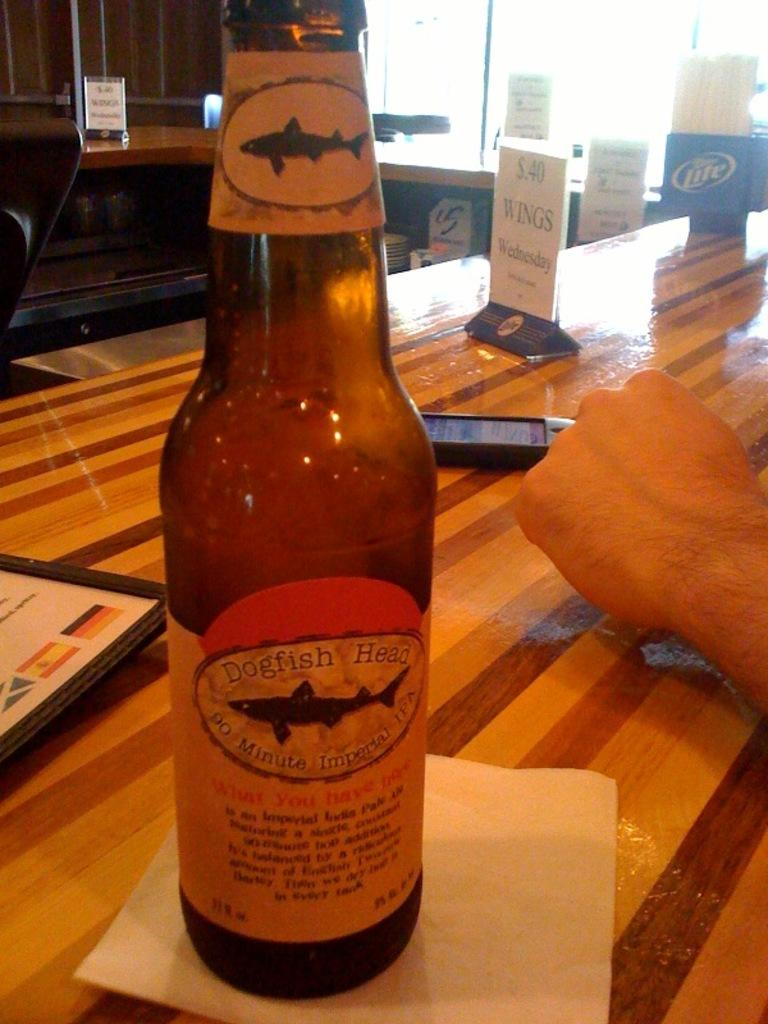<image>
Offer a succinct explanation of the picture presented. A bottle of beef with the words dogfsh head on the label. 